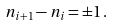<formula> <loc_0><loc_0><loc_500><loc_500>n _ { i + 1 } - n _ { i } = \pm 1 \, .</formula> 